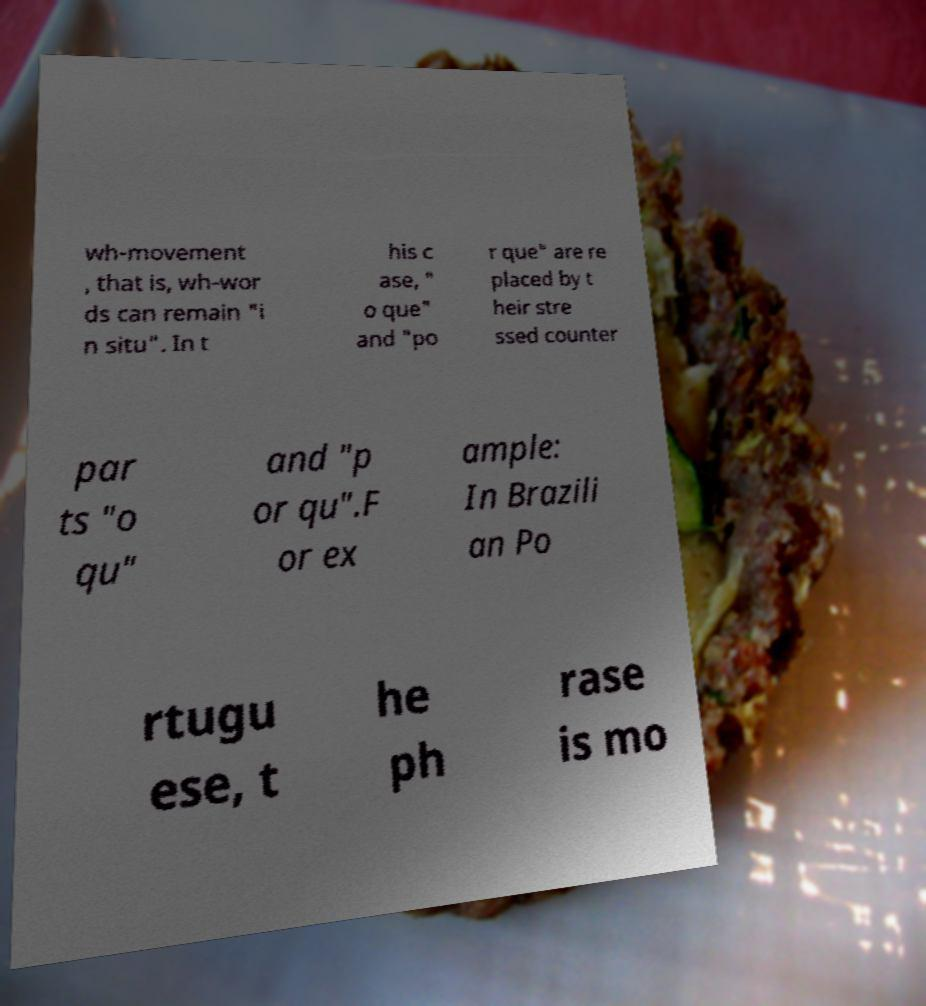Could you assist in decoding the text presented in this image and type it out clearly? wh-movement , that is, wh-wor ds can remain "i n situ". In t his c ase, " o que" and "po r que" are re placed by t heir stre ssed counter par ts "o qu" and "p or qu".F or ex ample: In Brazili an Po rtugu ese, t he ph rase is mo 